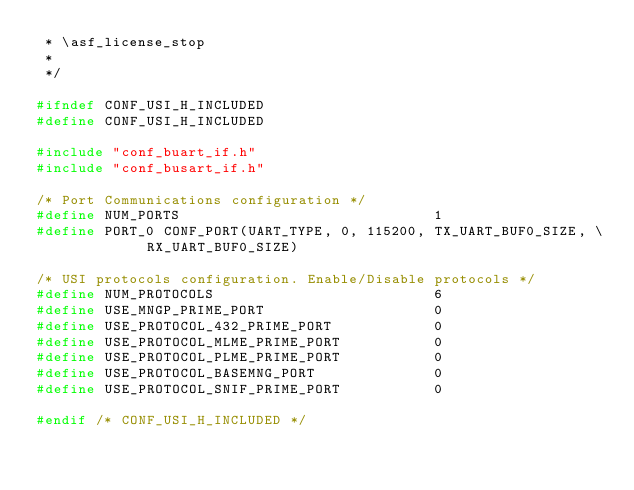<code> <loc_0><loc_0><loc_500><loc_500><_C_> * \asf_license_stop
 *
 */

#ifndef CONF_USI_H_INCLUDED
#define CONF_USI_H_INCLUDED

#include "conf_buart_if.h"
#include "conf_busart_if.h"

/* Port Communications configuration */
#define NUM_PORTS                              1
#define PORT_0 CONF_PORT(UART_TYPE, 0, 115200, TX_UART_BUF0_SIZE, \
						 RX_UART_BUF0_SIZE)

/* USI protocols configuration. Enable/Disable protocols */
#define NUM_PROTOCOLS                          6
#define USE_MNGP_PRIME_PORT                    0
#define USE_PROTOCOL_432_PRIME_PORT            0
#define USE_PROTOCOL_MLME_PRIME_PORT           0
#define USE_PROTOCOL_PLME_PRIME_PORT           0
#define USE_PROTOCOL_BASEMNG_PORT              0
#define USE_PROTOCOL_SNIF_PRIME_PORT           0

#endif /* CONF_USI_H_INCLUDED */
</code> 